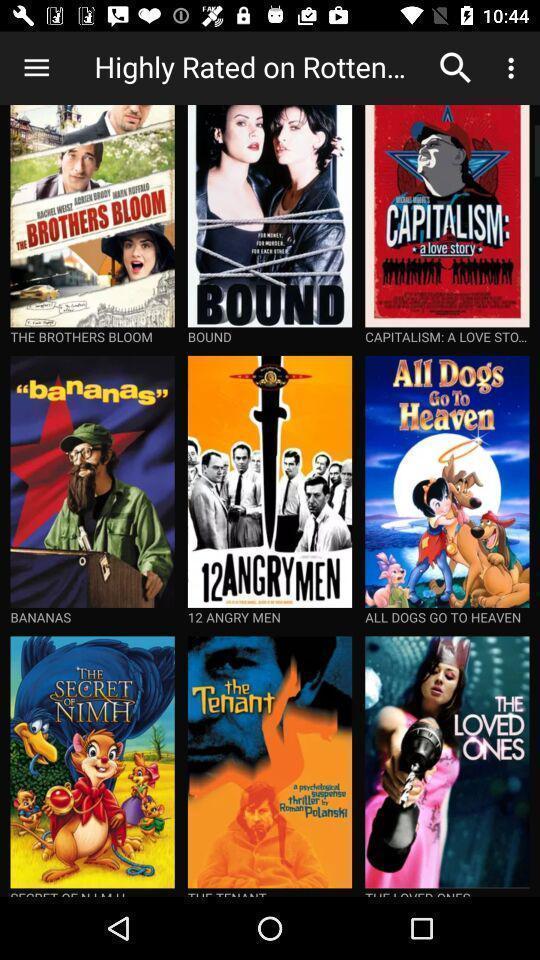Summarize the information in this screenshot. Page showing different movies available on an app. 